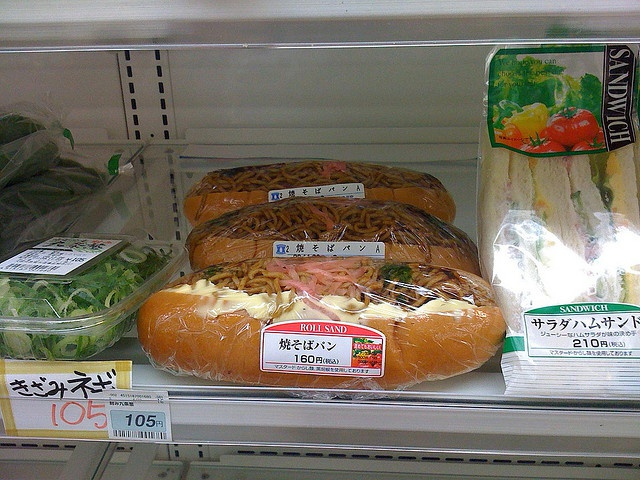Describe the objects in this image and their specific colors. I can see sandwich in darkgray, white, and gray tones, sandwich in darkgray, brown, lightgray, gray, and tan tones, sandwich in darkgray, maroon, black, and brown tones, and sandwich in darkgray, maroon, black, and gray tones in this image. 